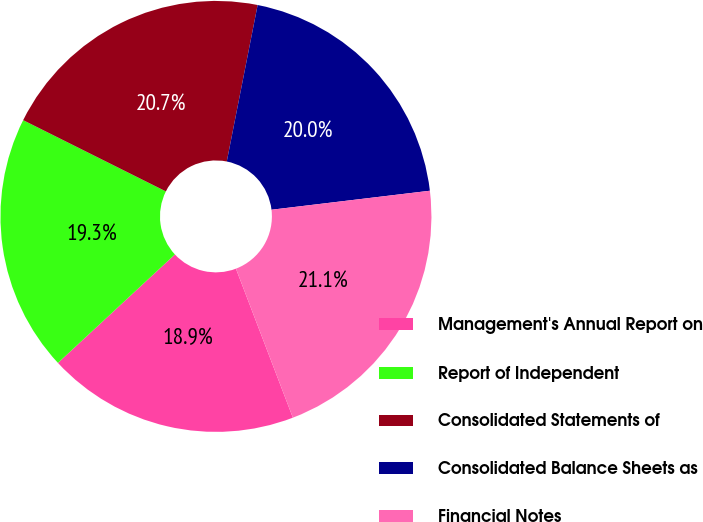Convert chart to OTSL. <chart><loc_0><loc_0><loc_500><loc_500><pie_chart><fcel>Management's Annual Report on<fcel>Report of Independent<fcel>Consolidated Statements of<fcel>Consolidated Balance Sheets as<fcel>Financial Notes<nl><fcel>18.91%<fcel>19.27%<fcel>20.73%<fcel>20.0%<fcel>21.09%<nl></chart> 